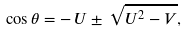<formula> <loc_0><loc_0><loc_500><loc_500>\cos \theta = - \, U \pm \, \sqrt { U ^ { 2 } - V } ,</formula> 